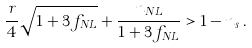<formula> <loc_0><loc_0><loc_500><loc_500>\frac { r } { 4 } \sqrt { 1 + 3 f _ { N L } } + \frac { n _ { N L } } { 1 + 3 f _ { N L } } > 1 - n _ { s } \, .</formula> 